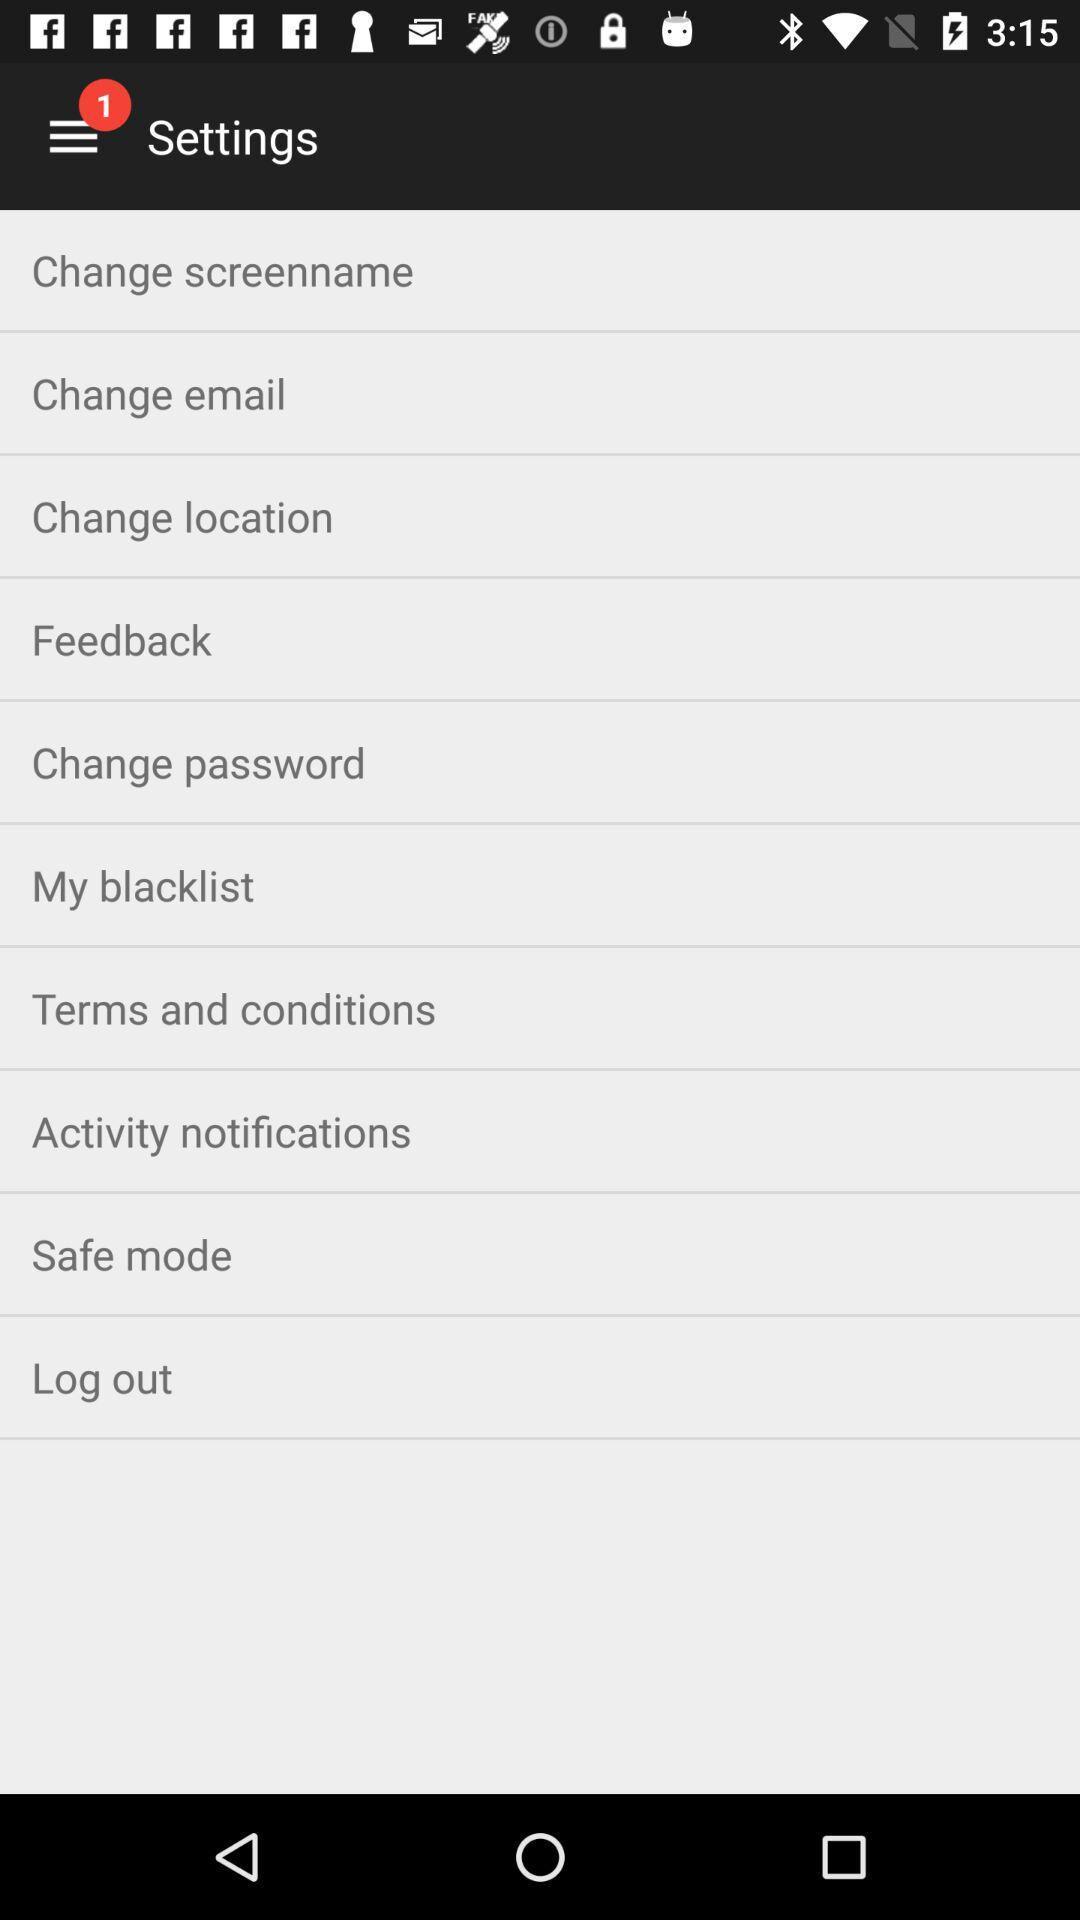What is the number of new notifications? The number of new notifications is 1. 